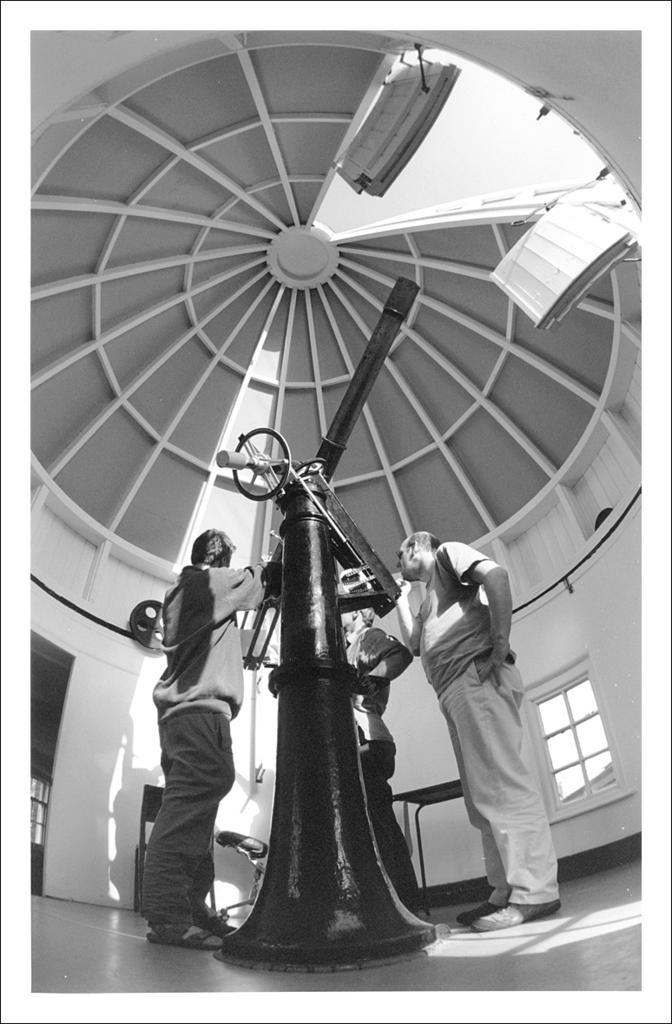In one or two sentences, can you explain what this image depicts? In this picture there are people in the center of the image and there are is a windmill in the center of the image, there is an open roof area at the top side of the image. 